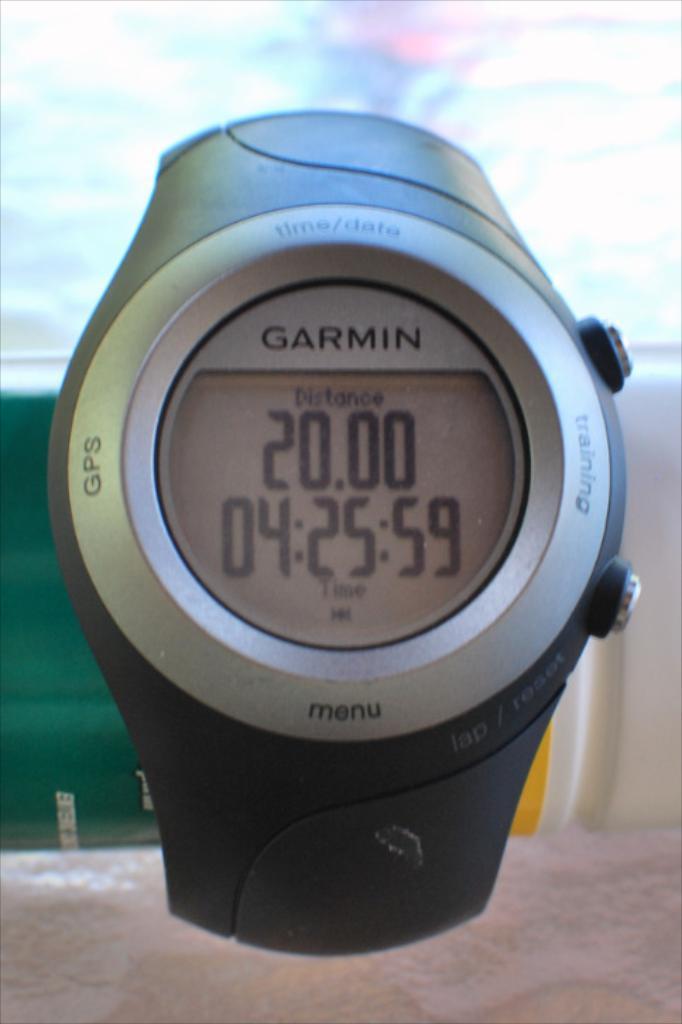What is the button on left for?
Your response must be concise. Gps. What does the top number represent?
Your answer should be very brief. Distance. 